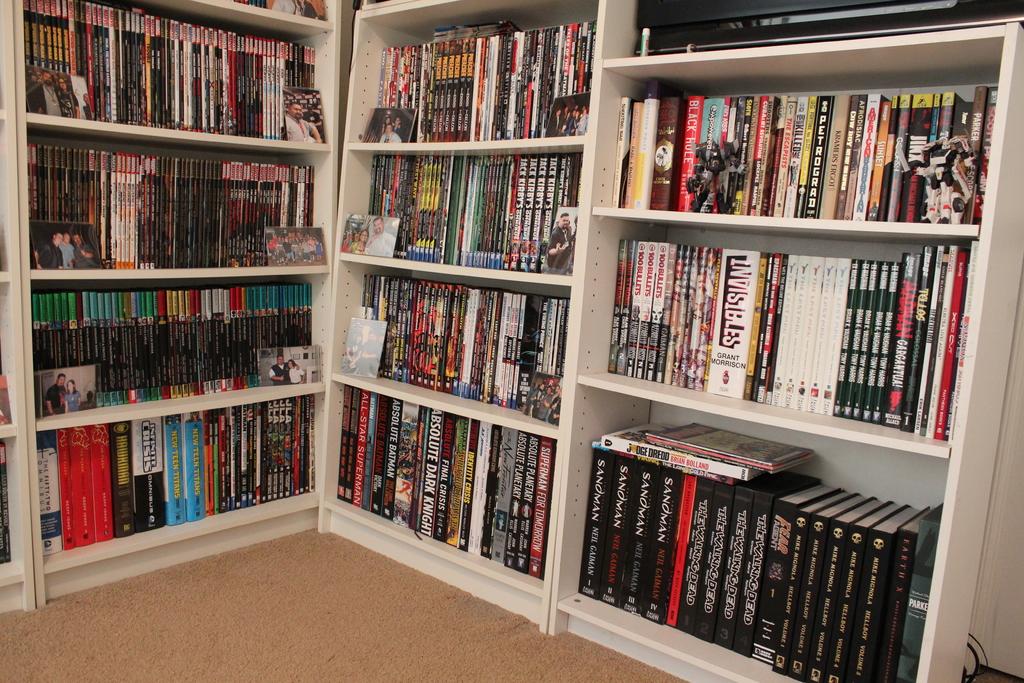Who is the author of invisibiles?
Offer a terse response. Grant morrison. What word is on four of the black books on the bottom right shelf, to the left of the red book?
Your answer should be very brief. Unanswerable. 